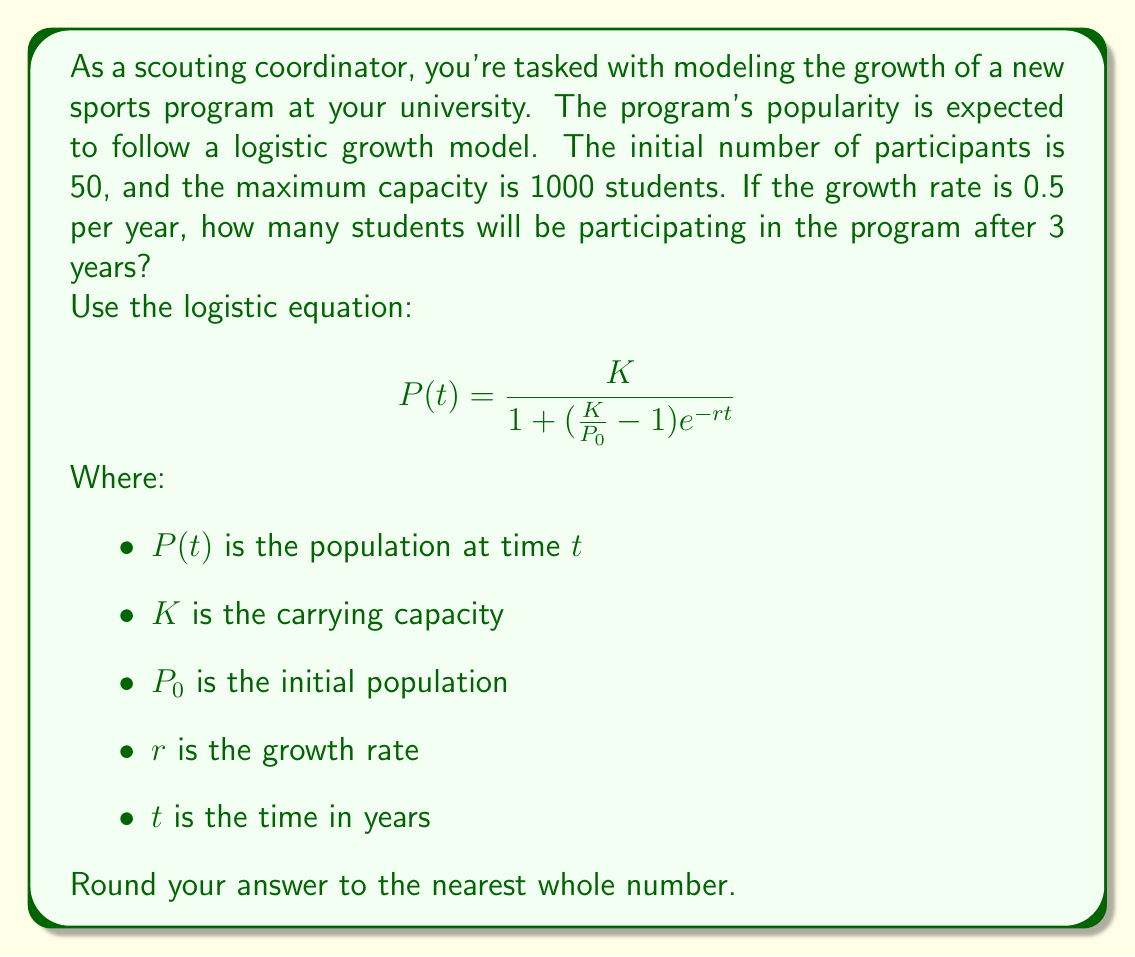Could you help me with this problem? To solve this problem, we'll use the logistic equation and plug in the given values:

$K = 1000$ (carrying capacity)
$P_0 = 50$ (initial population)
$r = 0.5$ (growth rate)
$t = 3$ (time in years)

Let's substitute these values into the equation:

$$P(3) = \frac{1000}{1 + (\frac{1000}{50} - 1)e^{-0.5 \cdot 3}}$$

Now, let's solve this step-by-step:

1) First, simplify the fraction inside the parentheses:
   $$\frac{1000}{50} - 1 = 20 - 1 = 19$$

2) Now our equation looks like this:
   $$P(3) = \frac{1000}{1 + 19e^{-1.5}}$$

3) Calculate $e^{-1.5}$:
   $e^{-1.5} \approx 0.2231$

4) Multiply:
   $19 \cdot 0.2231 \approx 4.2389$

5) Add 1:
   $1 + 4.2389 = 5.2389$

6) Finally, divide:
   $$P(3) = \frac{1000}{5.2389} \approx 190.8801$$

7) Rounding to the nearest whole number:
   $P(3) \approx 191$

Therefore, after 3 years, approximately 191 students will be participating in the program.
Answer: 191 students 